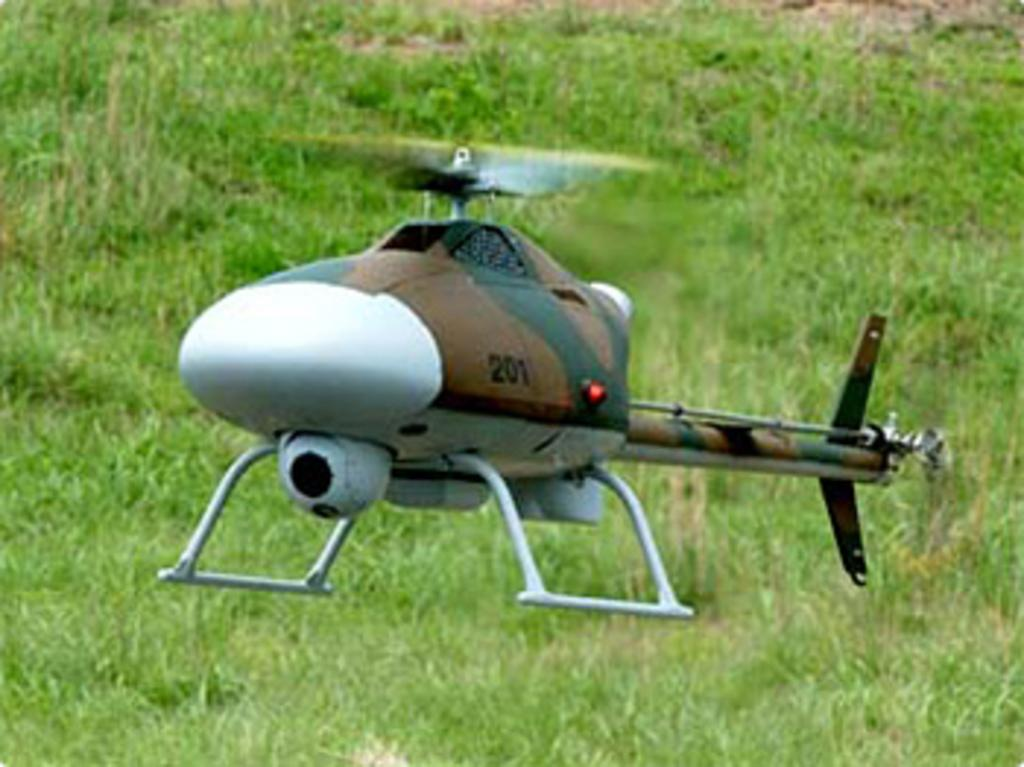What is the main subject of the image? The main subject of the image is a helicopter. What is the helicopter doing in the image? The helicopter is flying in the air. What can be seen in the background of the image? There is grass visible in the background of the image. What type of butter is being used to grease the helicopter blades in the image? There is no butter present in the image, nor is there any indication that the helicopter blades are being greased. 